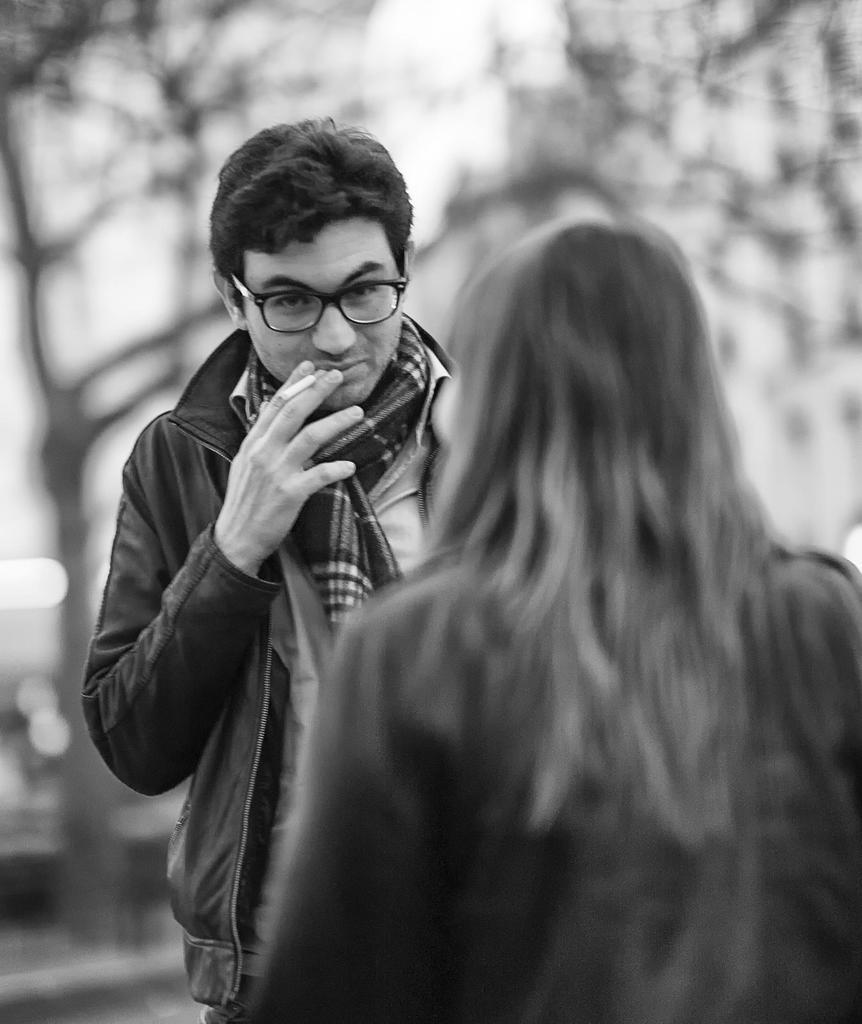How would you summarize this image in a sentence or two? In this picture we can see a man wore a jacket, spectacle and holding a cigarette with his hand and in front of him we can see a woman and in the background we can see trees and it is blur. 